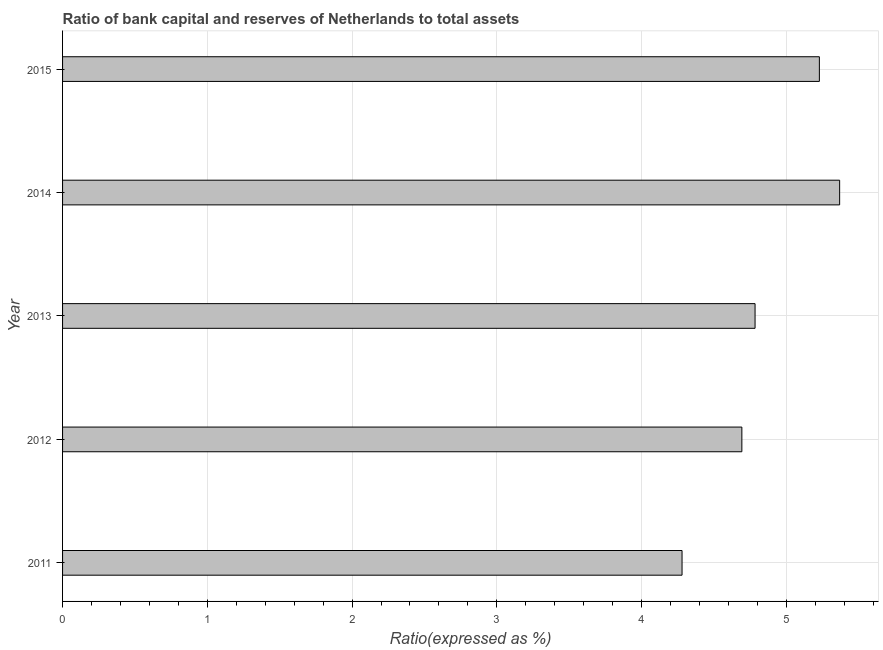Does the graph contain any zero values?
Keep it short and to the point. No. What is the title of the graph?
Offer a very short reply. Ratio of bank capital and reserves of Netherlands to total assets. What is the label or title of the X-axis?
Your response must be concise. Ratio(expressed as %). What is the bank capital to assets ratio in 2011?
Offer a terse response. 4.28. Across all years, what is the maximum bank capital to assets ratio?
Provide a short and direct response. 5.37. Across all years, what is the minimum bank capital to assets ratio?
Ensure brevity in your answer.  4.28. What is the sum of the bank capital to assets ratio?
Give a very brief answer. 24.35. What is the difference between the bank capital to assets ratio in 2012 and 2013?
Ensure brevity in your answer.  -0.09. What is the average bank capital to assets ratio per year?
Your answer should be very brief. 4.87. What is the median bank capital to assets ratio?
Your answer should be compact. 4.78. In how many years, is the bank capital to assets ratio greater than 4.2 %?
Provide a succinct answer. 5. Do a majority of the years between 2015 and 2012 (inclusive) have bank capital to assets ratio greater than 4.6 %?
Make the answer very short. Yes. Is the bank capital to assets ratio in 2011 less than that in 2013?
Make the answer very short. Yes. What is the difference between the highest and the second highest bank capital to assets ratio?
Your answer should be compact. 0.14. What is the difference between the highest and the lowest bank capital to assets ratio?
Provide a short and direct response. 1.09. In how many years, is the bank capital to assets ratio greater than the average bank capital to assets ratio taken over all years?
Offer a very short reply. 2. Are all the bars in the graph horizontal?
Your answer should be compact. Yes. How many years are there in the graph?
Offer a very short reply. 5. What is the Ratio(expressed as %) in 2011?
Give a very brief answer. 4.28. What is the Ratio(expressed as %) in 2012?
Your answer should be compact. 4.69. What is the Ratio(expressed as %) in 2013?
Give a very brief answer. 4.78. What is the Ratio(expressed as %) of 2014?
Your answer should be compact. 5.37. What is the Ratio(expressed as %) of 2015?
Provide a short and direct response. 5.23. What is the difference between the Ratio(expressed as %) in 2011 and 2012?
Make the answer very short. -0.41. What is the difference between the Ratio(expressed as %) in 2011 and 2013?
Ensure brevity in your answer.  -0.5. What is the difference between the Ratio(expressed as %) in 2011 and 2014?
Ensure brevity in your answer.  -1.09. What is the difference between the Ratio(expressed as %) in 2011 and 2015?
Your response must be concise. -0.95. What is the difference between the Ratio(expressed as %) in 2012 and 2013?
Offer a terse response. -0.09. What is the difference between the Ratio(expressed as %) in 2012 and 2014?
Offer a very short reply. -0.68. What is the difference between the Ratio(expressed as %) in 2012 and 2015?
Provide a short and direct response. -0.54. What is the difference between the Ratio(expressed as %) in 2013 and 2014?
Offer a very short reply. -0.58. What is the difference between the Ratio(expressed as %) in 2013 and 2015?
Give a very brief answer. -0.44. What is the difference between the Ratio(expressed as %) in 2014 and 2015?
Your response must be concise. 0.14. What is the ratio of the Ratio(expressed as %) in 2011 to that in 2012?
Provide a short and direct response. 0.91. What is the ratio of the Ratio(expressed as %) in 2011 to that in 2013?
Your answer should be very brief. 0.9. What is the ratio of the Ratio(expressed as %) in 2011 to that in 2014?
Offer a very short reply. 0.8. What is the ratio of the Ratio(expressed as %) in 2011 to that in 2015?
Your answer should be compact. 0.82. What is the ratio of the Ratio(expressed as %) in 2012 to that in 2013?
Provide a short and direct response. 0.98. What is the ratio of the Ratio(expressed as %) in 2012 to that in 2014?
Provide a short and direct response. 0.87. What is the ratio of the Ratio(expressed as %) in 2012 to that in 2015?
Give a very brief answer. 0.9. What is the ratio of the Ratio(expressed as %) in 2013 to that in 2014?
Your answer should be very brief. 0.89. What is the ratio of the Ratio(expressed as %) in 2013 to that in 2015?
Provide a short and direct response. 0.92. What is the ratio of the Ratio(expressed as %) in 2014 to that in 2015?
Provide a short and direct response. 1.03. 